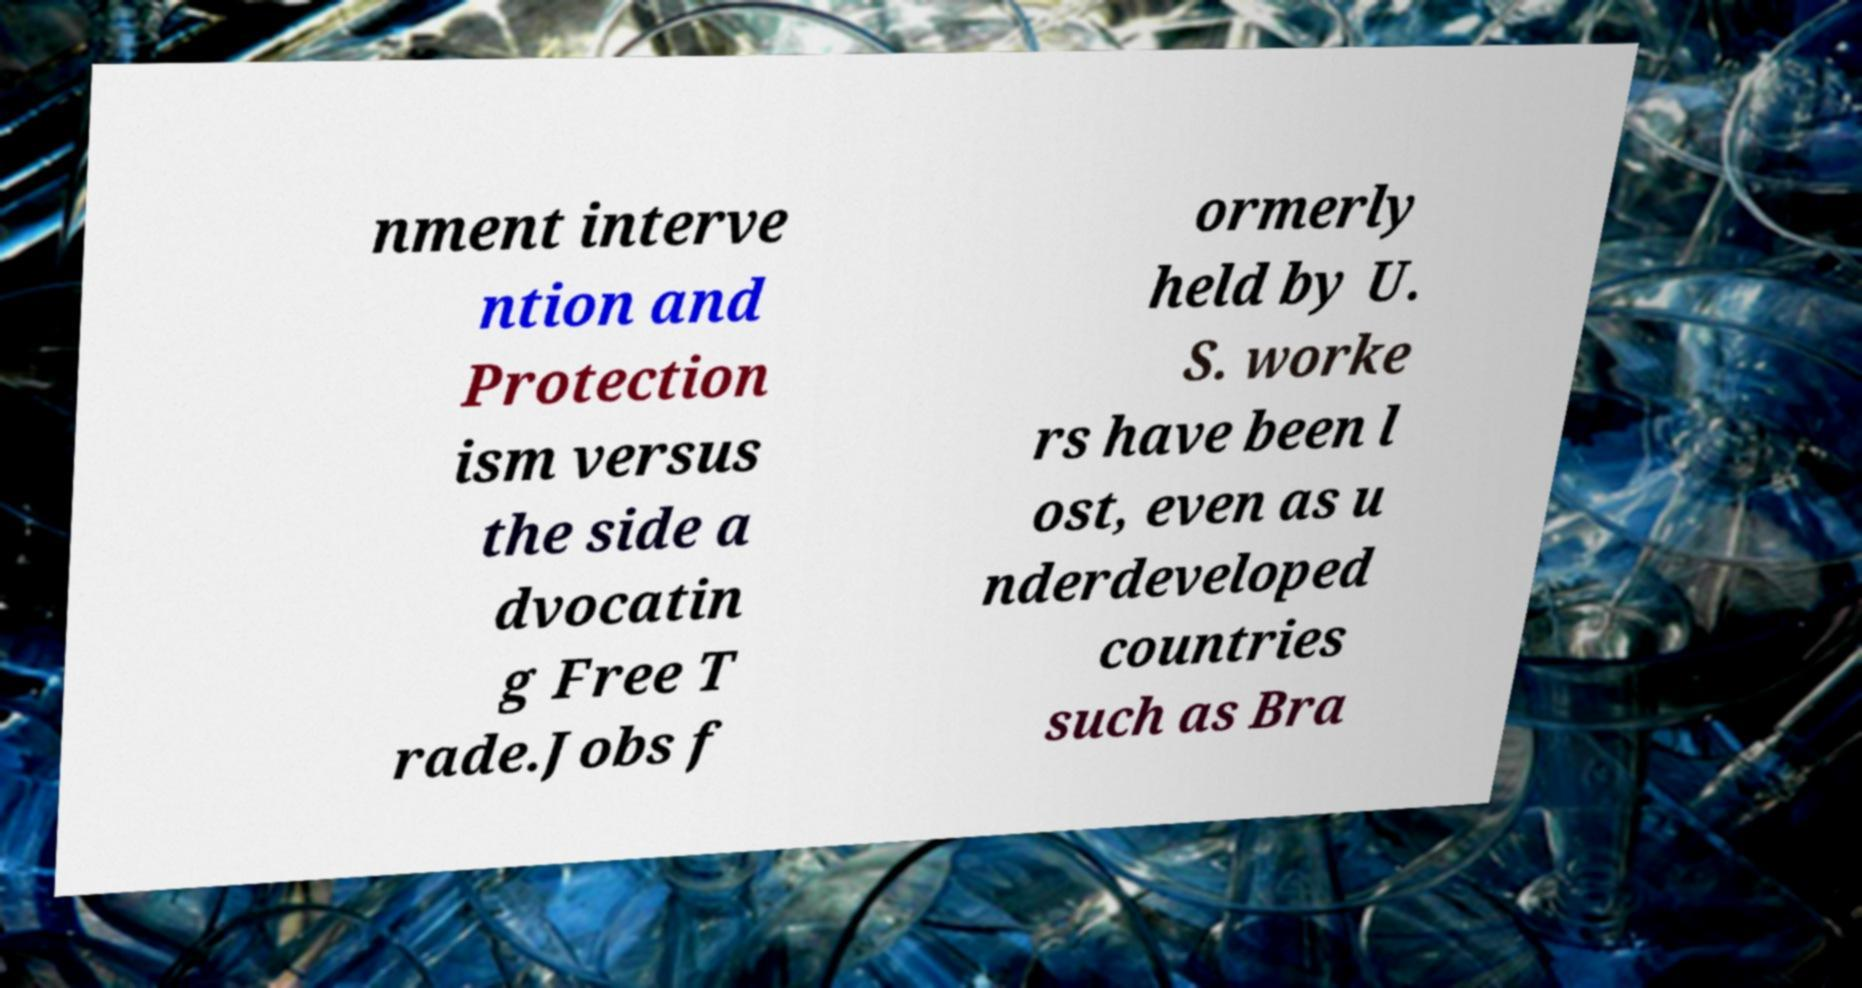Please identify and transcribe the text found in this image. nment interve ntion and Protection ism versus the side a dvocatin g Free T rade.Jobs f ormerly held by U. S. worke rs have been l ost, even as u nderdeveloped countries such as Bra 